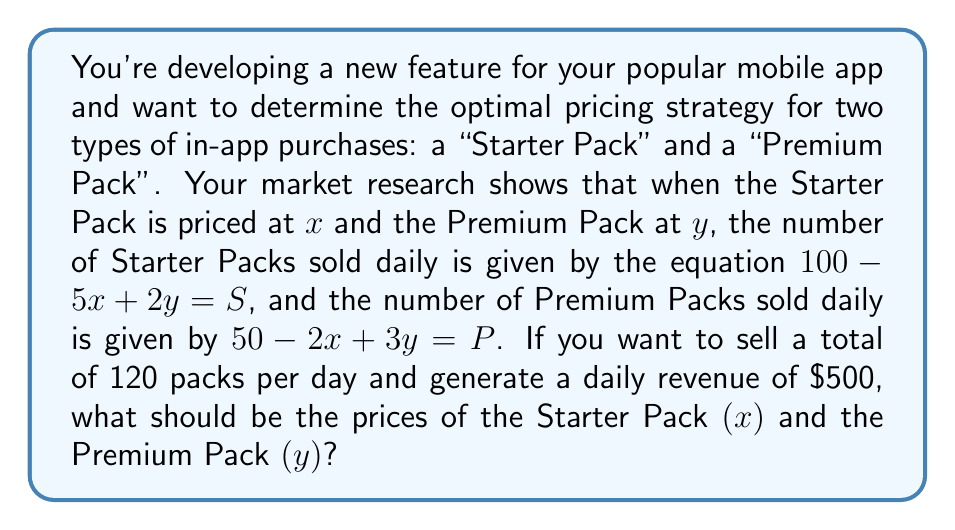Give your solution to this math problem. Let's approach this step-by-step:

1) We have two equations from the given information:
   $100 - 5x + 2y = S$ (Starter Pack sales)
   $50 - 2x + 3y = P$ (Premium Pack sales)

2) We're told that the total number of packs sold should be 120:
   $S + P = 120$

3) Substituting the equations from step 1 into step 2:
   $(100 - 5x + 2y) + (50 - 2x + 3y) = 120$

4) Simplifying:
   $150 - 7x + 5y = 120$

5) We're also told that the daily revenue should be $500. This can be represented as:
   $xS + yP = 500$

6) Substituting the equations from step 1 into this revenue equation:
   $x(100 - 5x + 2y) + y(50 - 2x + 3y) = 500$

7) Now we have a system of two equations:
   $150 - 7x + 5y = 120$
   $100x - 5x^2 + 2xy + 50y - 2xy + 3y^2 = 500$

8) Simplifying the second equation:
   $100x - 5x^2 + 50y + 3y^2 = 500$

9) From the first equation:
   $7x - 5y = 30$
   $x = \frac{30 + 5y}{7}$

10) Substituting this into the second equation:
    $100(\frac{30 + 5y}{7}) - 5(\frac{30 + 5y}{7})^2 + 50y + 3y^2 = 500$

11) This results in a quadratic equation in terms of $y$. Solving this equation (which is a complex process involving expanding, collecting like terms, and using the quadratic formula) gives us:
    $y = 10$

12) Substituting this back into the equation from step 9:
    $x = \frac{30 + 5(10)}{7} = 10$

Therefore, the Starter Pack should be priced at $10 and the Premium Pack at $10 as well.
Answer: $x = 10, y = 10$ 